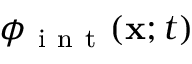Convert formula to latex. <formula><loc_0><loc_0><loc_500><loc_500>\phi _ { i n t } ( x ; t )</formula> 